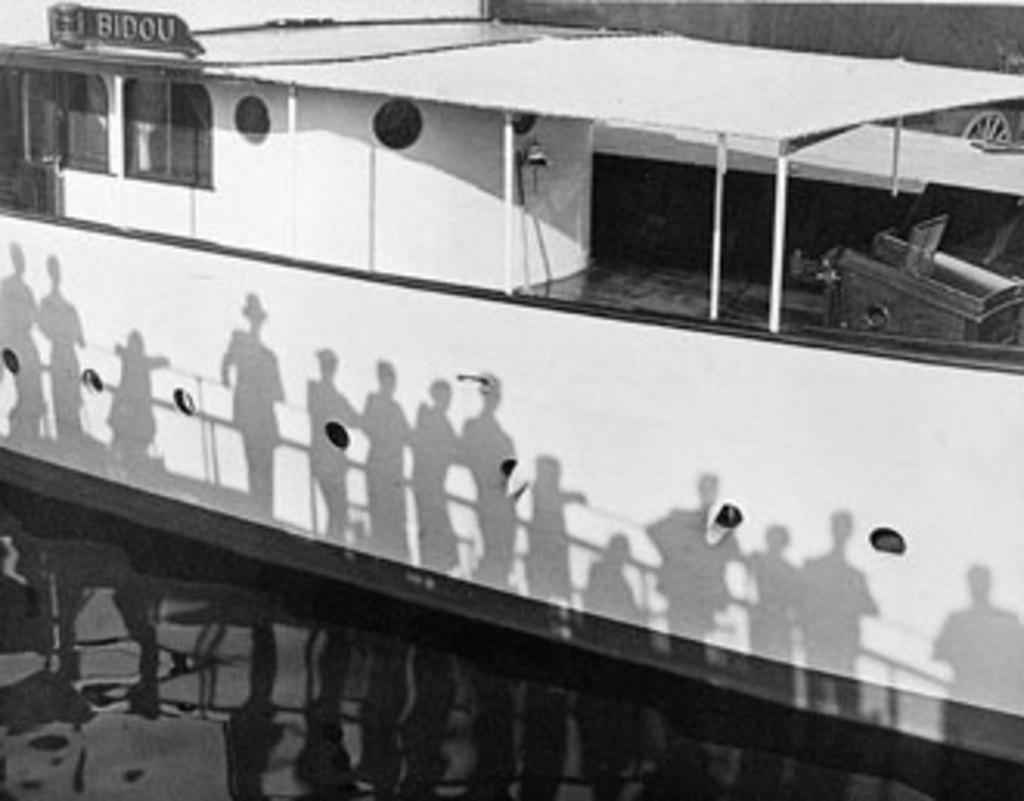Provide a one-sentence caption for the provided image. A riverboat with the word Bidou written on the top of it. 